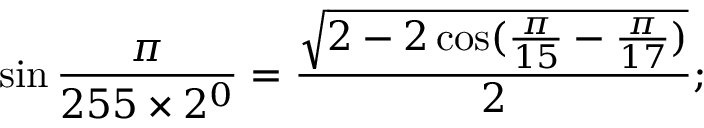Convert formula to latex. <formula><loc_0><loc_0><loc_500><loc_500>\sin { \frac { \pi } { 2 5 5 \times 2 ^ { 0 } } } = { \frac { \sqrt { 2 - 2 \cos ( { \frac { \pi } { 1 5 } } - { \frac { \pi } { 1 7 } } ) } } { 2 } } ;</formula> 